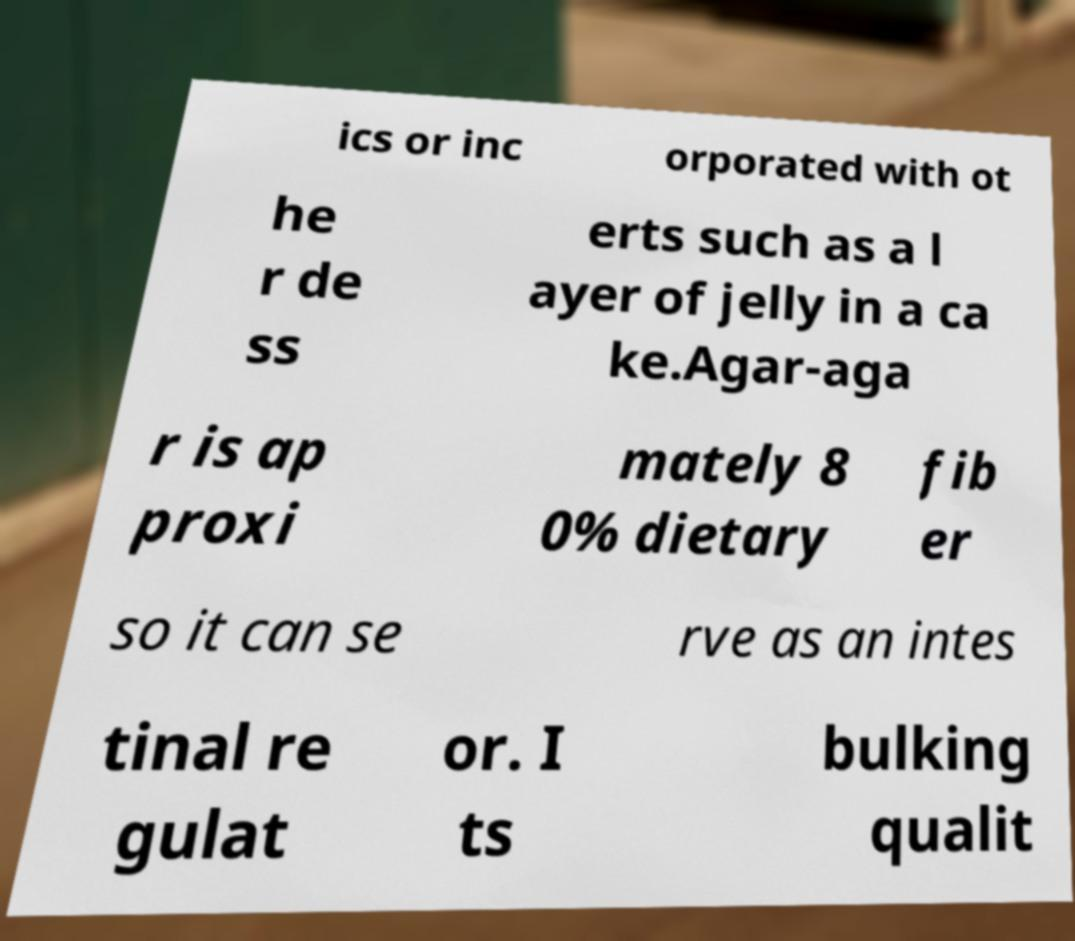I need the written content from this picture converted into text. Can you do that? ics or inc orporated with ot he r de ss erts such as a l ayer of jelly in a ca ke.Agar-aga r is ap proxi mately 8 0% dietary fib er so it can se rve as an intes tinal re gulat or. I ts bulking qualit 